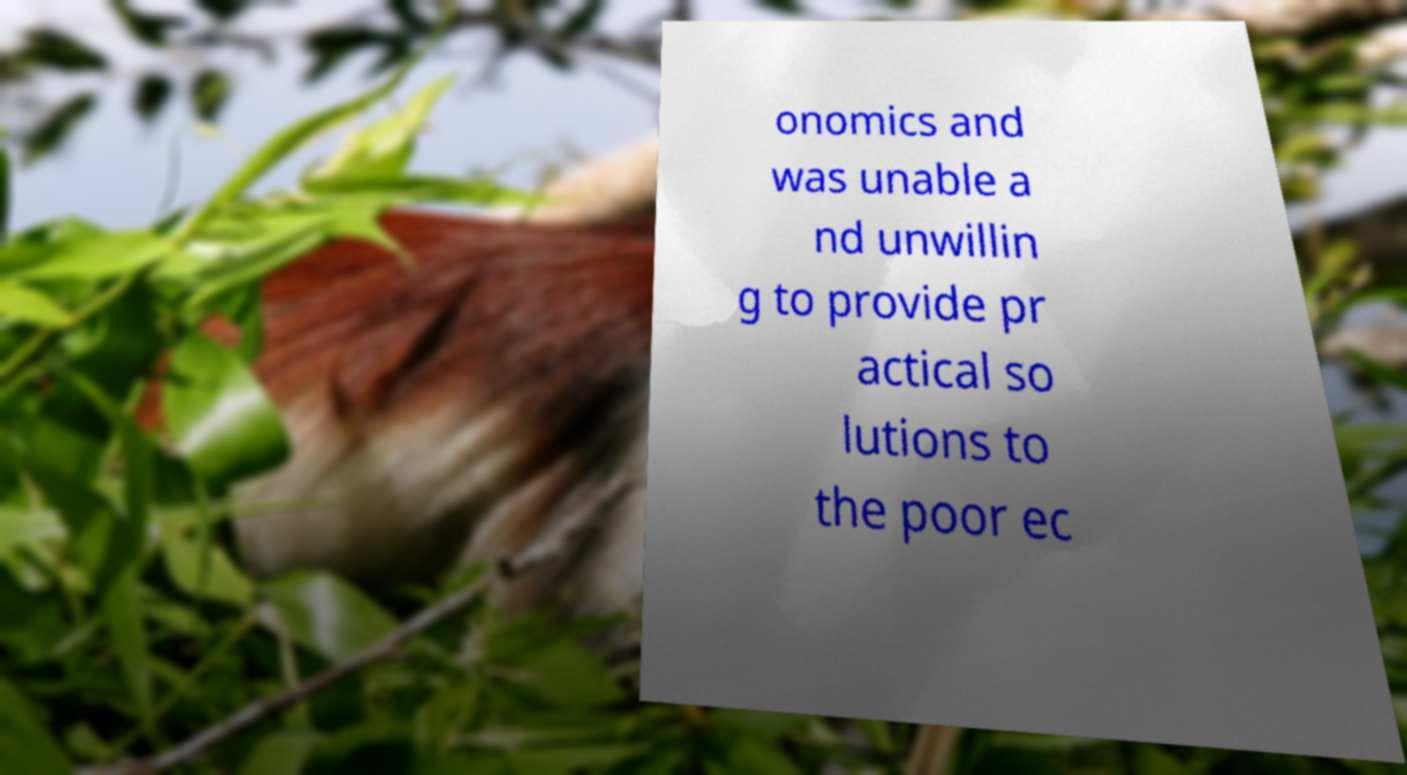Could you assist in decoding the text presented in this image and type it out clearly? onomics and was unable a nd unwillin g to provide pr actical so lutions to the poor ec 